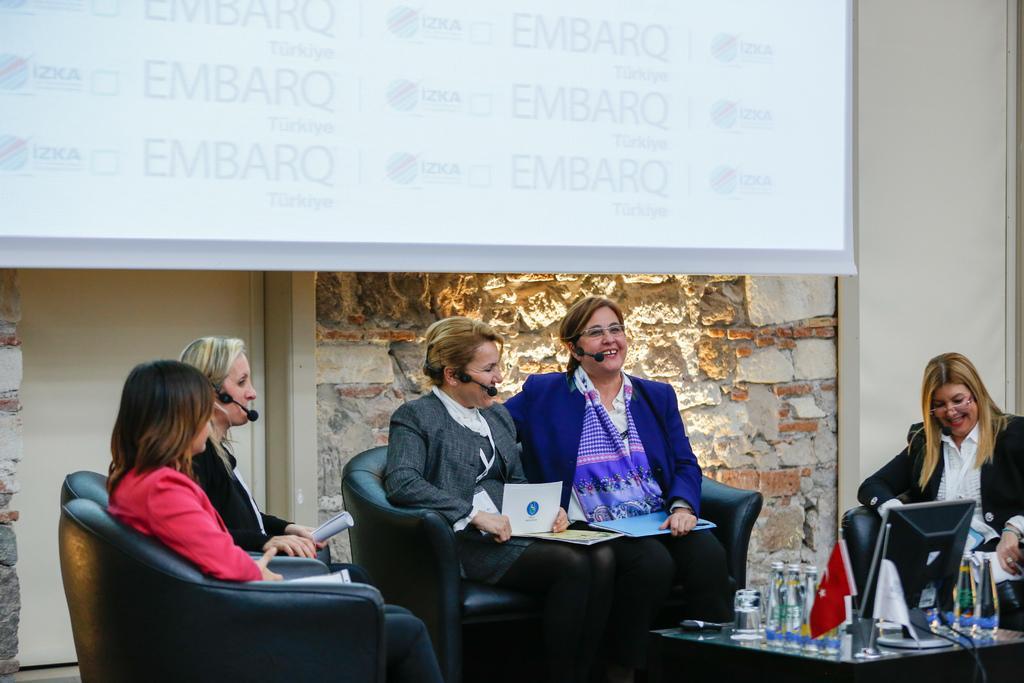Describe this image in one or two sentences. At the top of the image we can see a display screen to the wall. At the bottom of the image we can see sitting on the couches and a table is placed in front of them. On the table there are disposable bottles, flags, television screen and glass tumblers. 